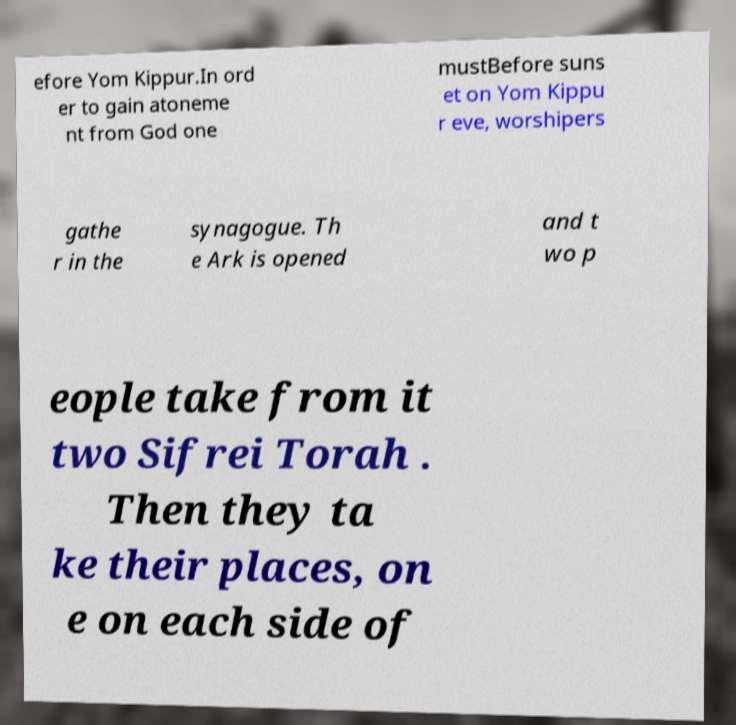There's text embedded in this image that I need extracted. Can you transcribe it verbatim? efore Yom Kippur.In ord er to gain atoneme nt from God one mustBefore suns et on Yom Kippu r eve, worshipers gathe r in the synagogue. Th e Ark is opened and t wo p eople take from it two Sifrei Torah . Then they ta ke their places, on e on each side of 